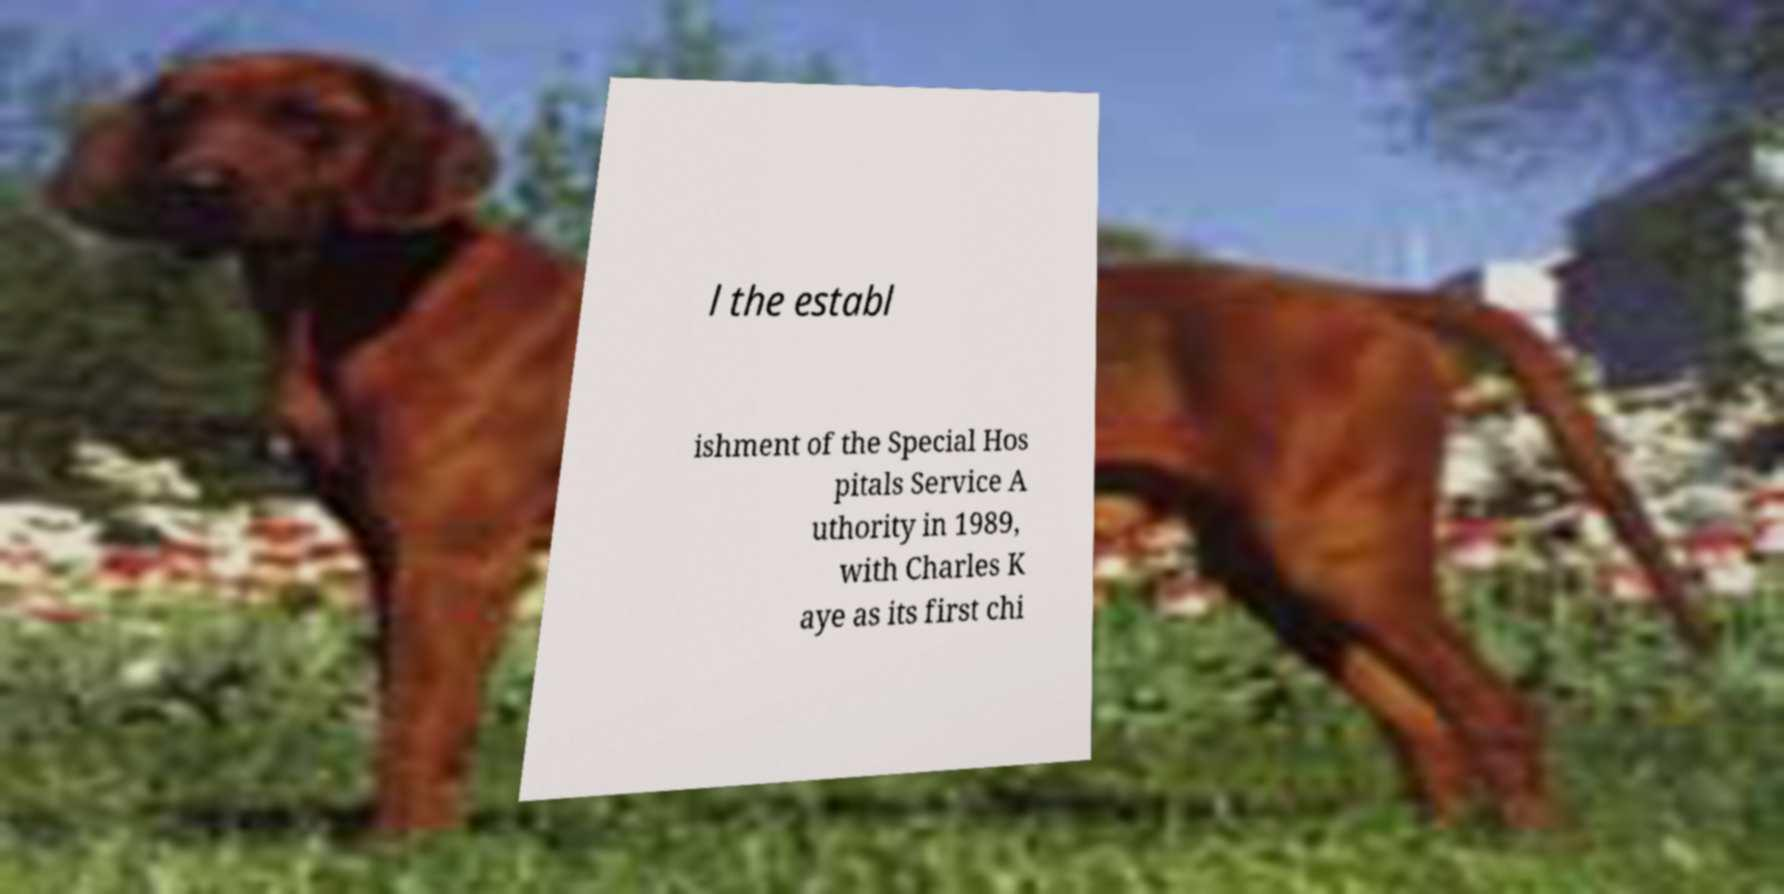Please read and relay the text visible in this image. What does it say? l the establ ishment of the Special Hos pitals Service A uthority in 1989, with Charles K aye as its first chi 